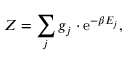<formula> <loc_0><loc_0><loc_500><loc_500>Z = \sum _ { j } g _ { j } \cdot e ^ { - \beta E _ { j } } ,</formula> 